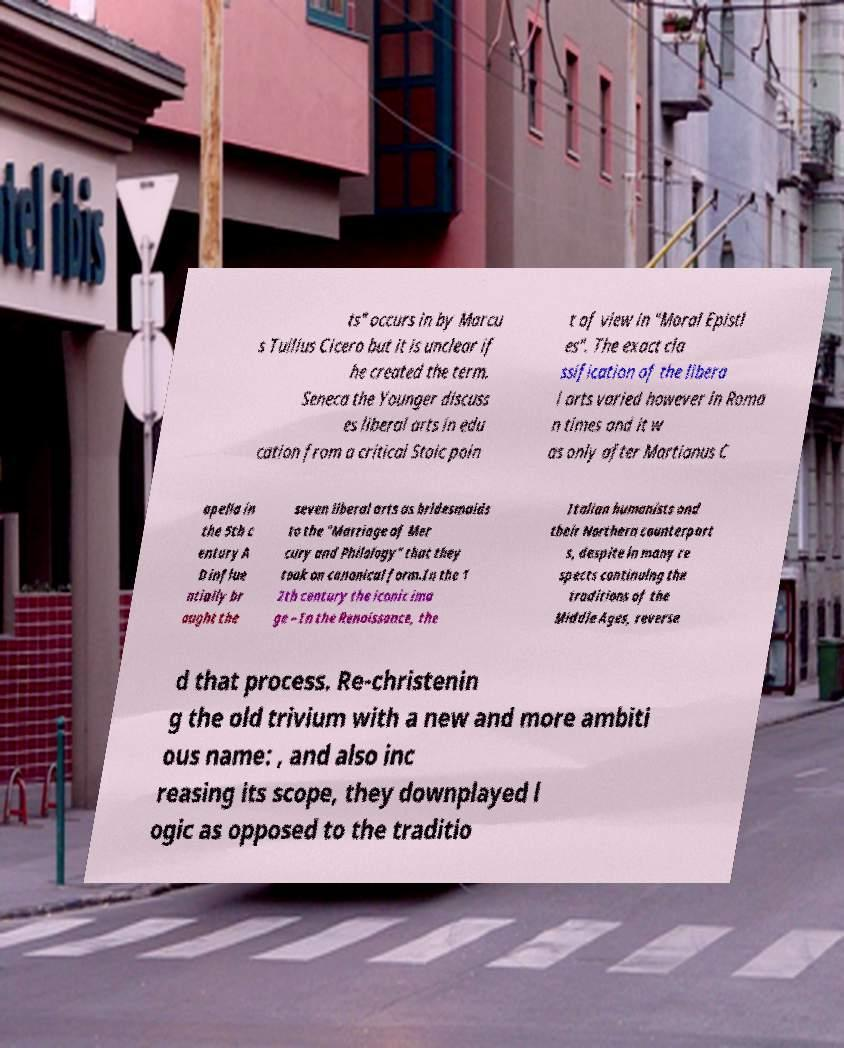There's text embedded in this image that I need extracted. Can you transcribe it verbatim? ts" occurs in by Marcu s Tullius Cicero but it is unclear if he created the term. Seneca the Younger discuss es liberal arts in edu cation from a critical Stoic poin t of view in "Moral Epistl es". The exact cla ssification of the libera l arts varied however in Roma n times and it w as only after Martianus C apella in the 5th c entury A D influe ntially br ought the seven liberal arts as bridesmaids to the "Marriage of Mer cury and Philology" that they took on canonical form.In the 1 2th century the iconic ima ge – In the Renaissance, the Italian humanists and their Northern counterpart s, despite in many re spects continuing the traditions of the Middle Ages, reverse d that process. Re-christenin g the old trivium with a new and more ambiti ous name: , and also inc reasing its scope, they downplayed l ogic as opposed to the traditio 